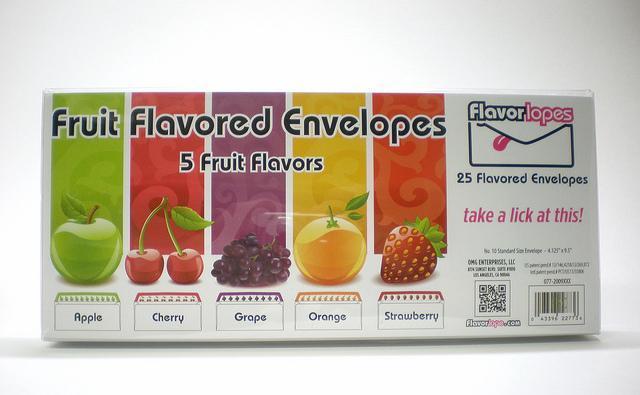How many flavors are available?
Give a very brief answer. 5. 